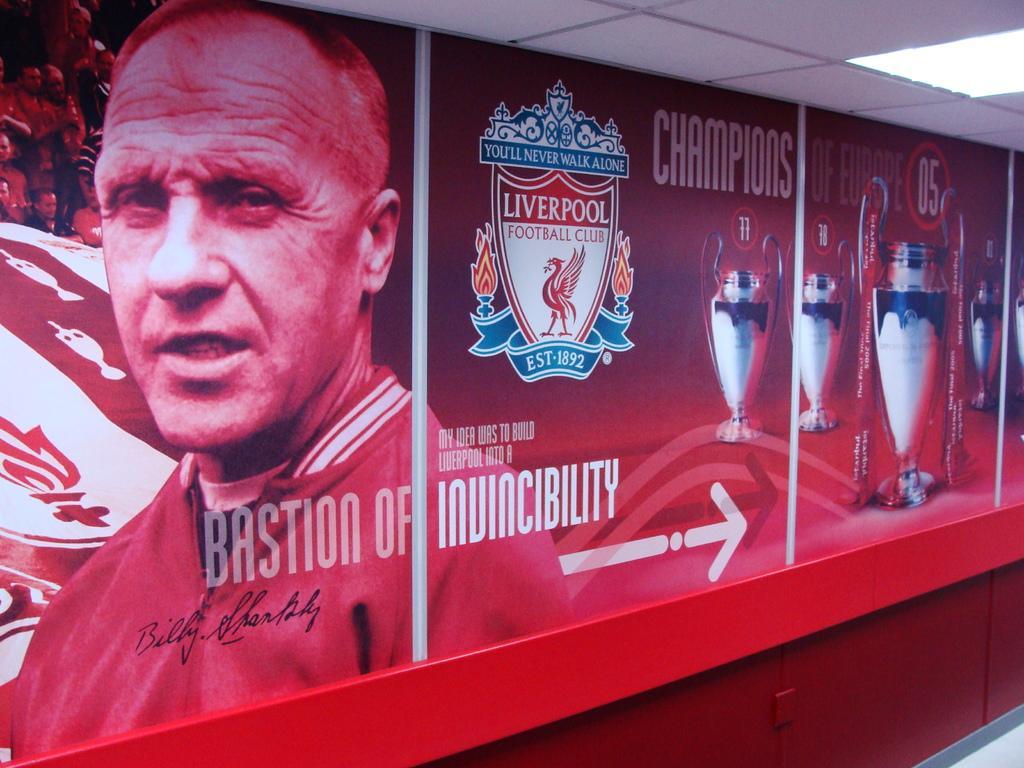In one or two sentences, can you explain what this image depicts? In this image there is a wall poster as we can see in the middle of this image. There is a person's image is on the left side of this image and there are some picture of a cups as we can see on the right side of this image, and there is a logo of a football club in the middle of this image. There is some text written in the bottom of this poster. 